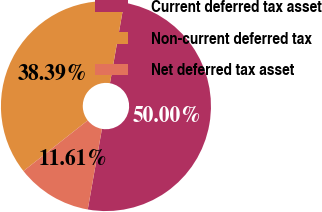Convert chart to OTSL. <chart><loc_0><loc_0><loc_500><loc_500><pie_chart><fcel>Current deferred tax asset<fcel>Non-current deferred tax<fcel>Net deferred tax asset<nl><fcel>50.0%<fcel>38.39%<fcel>11.61%<nl></chart> 